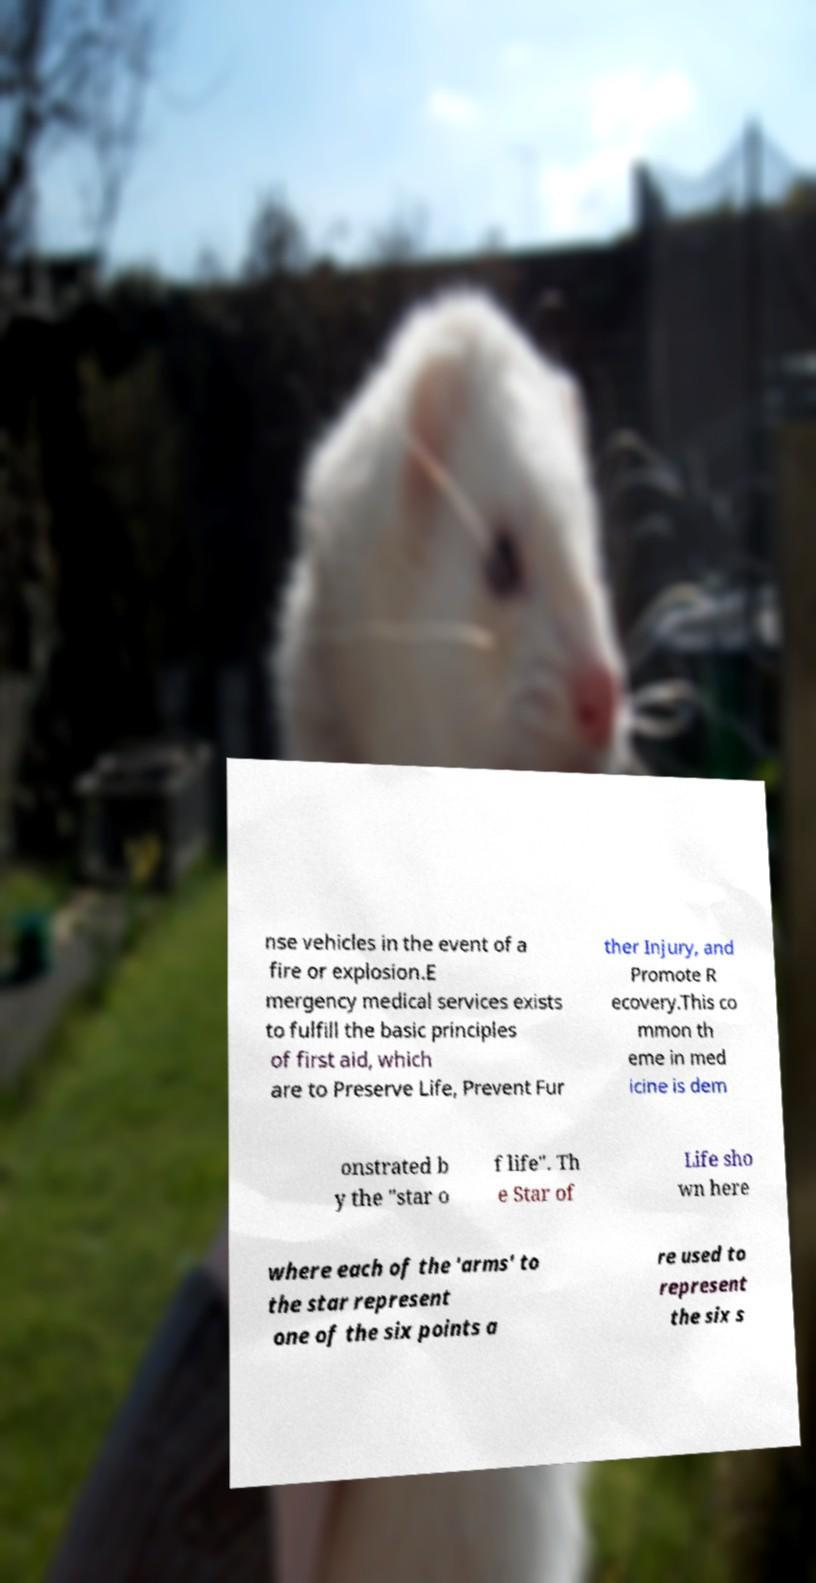Could you assist in decoding the text presented in this image and type it out clearly? nse vehicles in the event of a fire or explosion.E mergency medical services exists to fulfill the basic principles of first aid, which are to Preserve Life, Prevent Fur ther Injury, and Promote R ecovery.This co mmon th eme in med icine is dem onstrated b y the "star o f life". Th e Star of Life sho wn here where each of the 'arms' to the star represent one of the six points a re used to represent the six s 